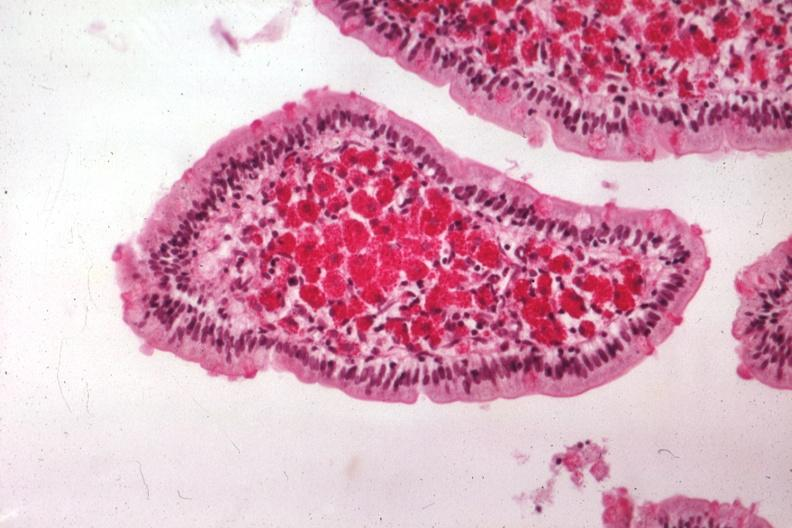s myoma lesion present?
Answer the question using a single word or phrase. No 